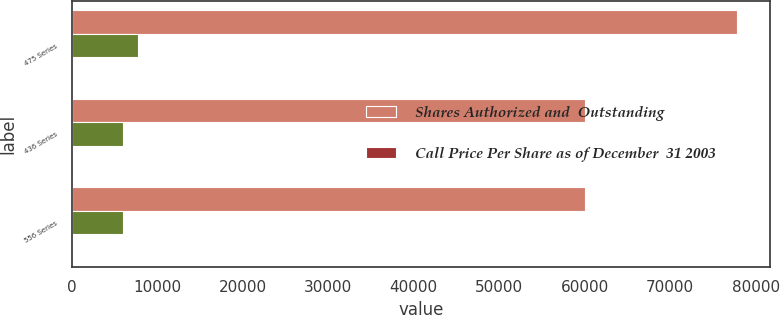<chart> <loc_0><loc_0><loc_500><loc_500><stacked_bar_chart><ecel><fcel>475 Series<fcel>436 Series<fcel>556 Series<nl><fcel>Shares Authorized and  Outstanding<fcel>77798<fcel>60000<fcel>60000<nl><fcel>nan<fcel>7780<fcel>6000<fcel>6000<nl><fcel>Call Price Per Share as of December  31 2003<fcel>105<fcel>104.57<fcel>102.59<nl></chart> 